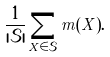<formula> <loc_0><loc_0><loc_500><loc_500>\frac { 1 } { | \mathcal { S } | } \sum _ { X \in \mathcal { S } } m ( X ) .</formula> 